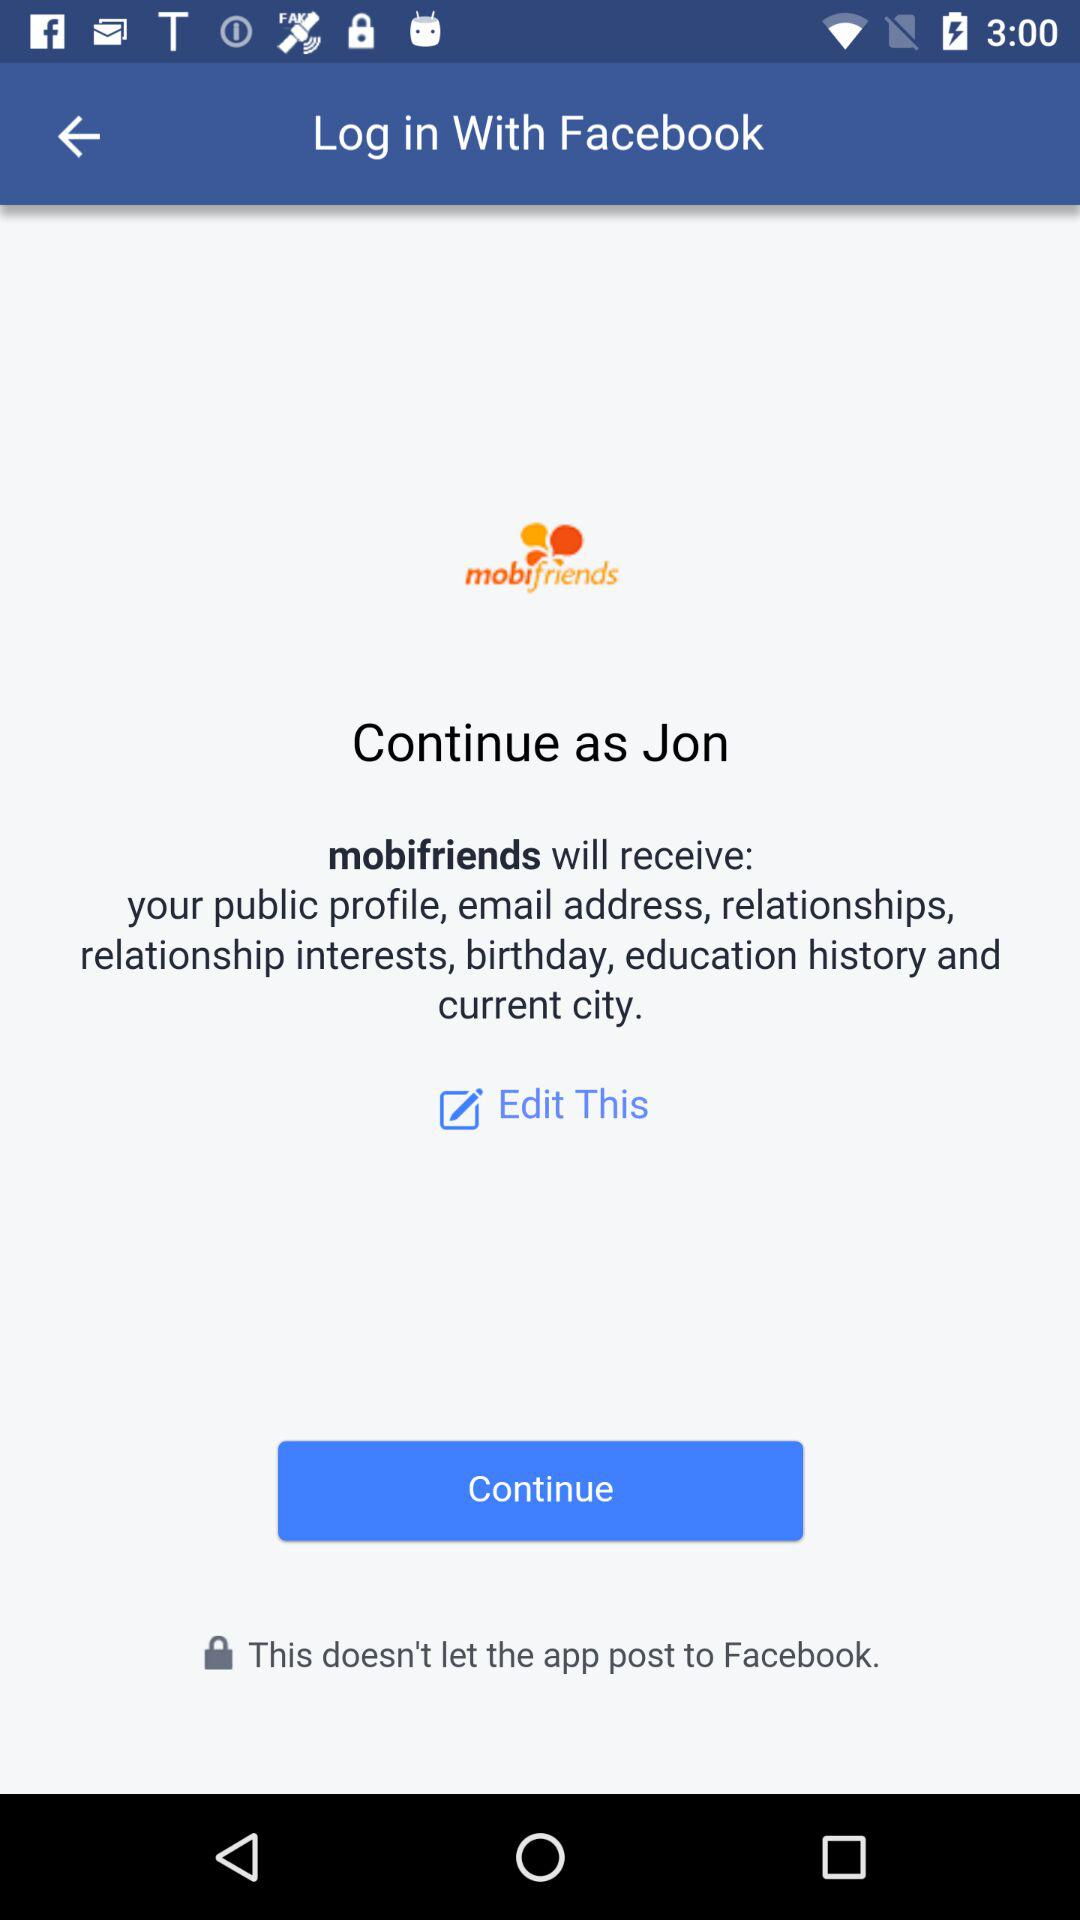What is the user name? The user name is Jon. 